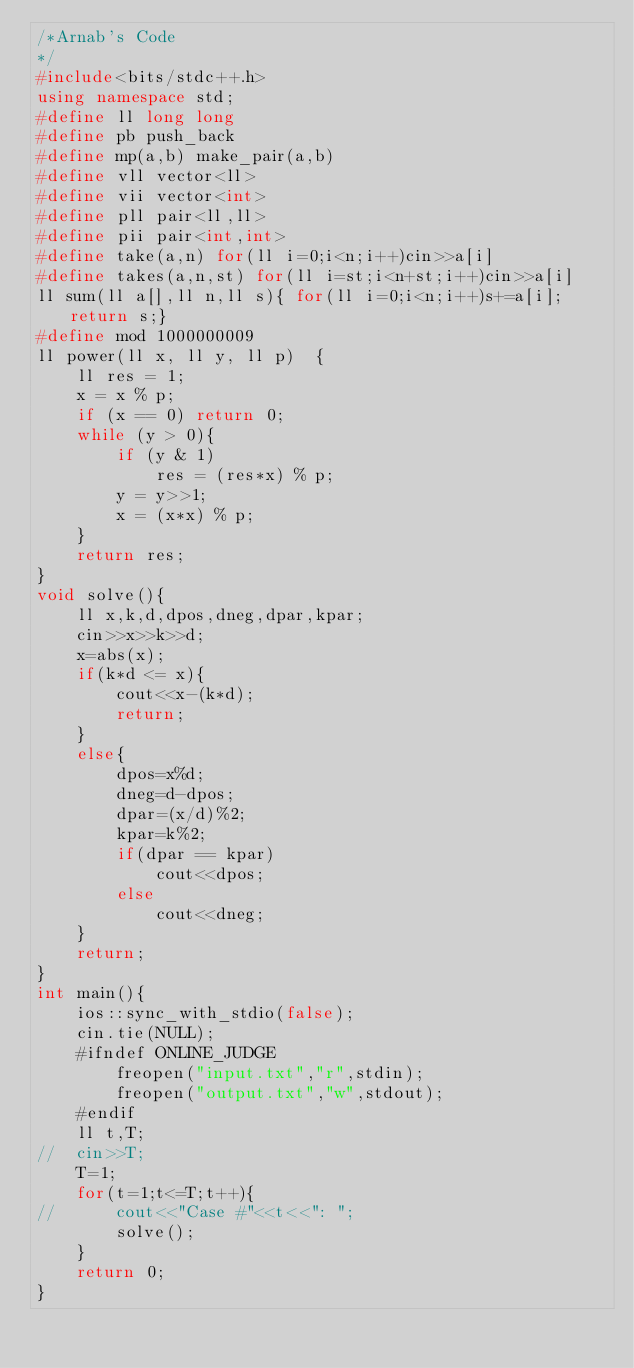<code> <loc_0><loc_0><loc_500><loc_500><_C++_>/*Arnab's Code
*/
#include<bits/stdc++.h>
using namespace std;
#define ll long long
#define pb push_back
#define mp(a,b) make_pair(a,b)
#define vll vector<ll>
#define vii vector<int>
#define pll pair<ll,ll>
#define pii pair<int,int>
#define take(a,n) for(ll i=0;i<n;i++)cin>>a[i]
#define takes(a,n,st) for(ll i=st;i<n+st;i++)cin>>a[i]
ll sum(ll a[],ll n,ll s){ for(ll i=0;i<n;i++)s+=a[i]; return s;}
#define mod 1000000009
ll power(ll x, ll y, ll p)  {  
    ll res = 1;  
    x = x % p;   
    if (x == 0) return 0;  
    while (y > 0){  
        if (y & 1)  
            res = (res*x) % p;  
        y = y>>1;
        x = (x*x) % p;  
    }  
    return res;  
}
void solve(){
	ll x,k,d,dpos,dneg,dpar,kpar;
	cin>>x>>k>>d;
	x=abs(x);
	if(k*d <= x){
		cout<<x-(k*d);
		return;
	}
	else{
		dpos=x%d;
		dneg=d-dpos;
		dpar=(x/d)%2;
		kpar=k%2;
		if(dpar == kpar)
			cout<<dpos;
		else
			cout<<dneg;
	}
	return;
}
int main(){
	ios::sync_with_stdio(false);
	cin.tie(NULL);
	#ifndef ONLINE_JUDGE
		freopen("input.txt","r",stdin);
		freopen("output.txt","w",stdout);
	#endif
	ll t,T;
//	cin>>T;
	T=1;
	for(t=1;t<=T;t++){
//		cout<<"Case #"<<t<<": ";
		solve();
	}
	return 0;
}</code> 